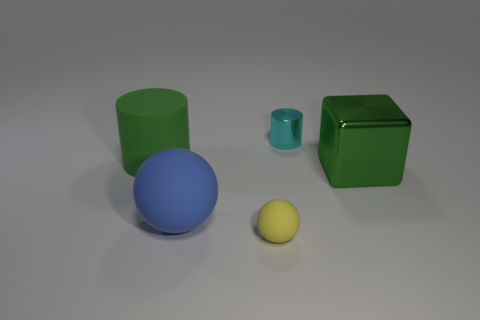Which object seems to be at the forefront? The blue sphere seems to be at the forefront, as it is the largest object closest to the point of view. 